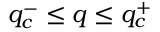<formula> <loc_0><loc_0><loc_500><loc_500>q _ { c } ^ { - } \leq q \leq q _ { c } ^ { + }</formula> 